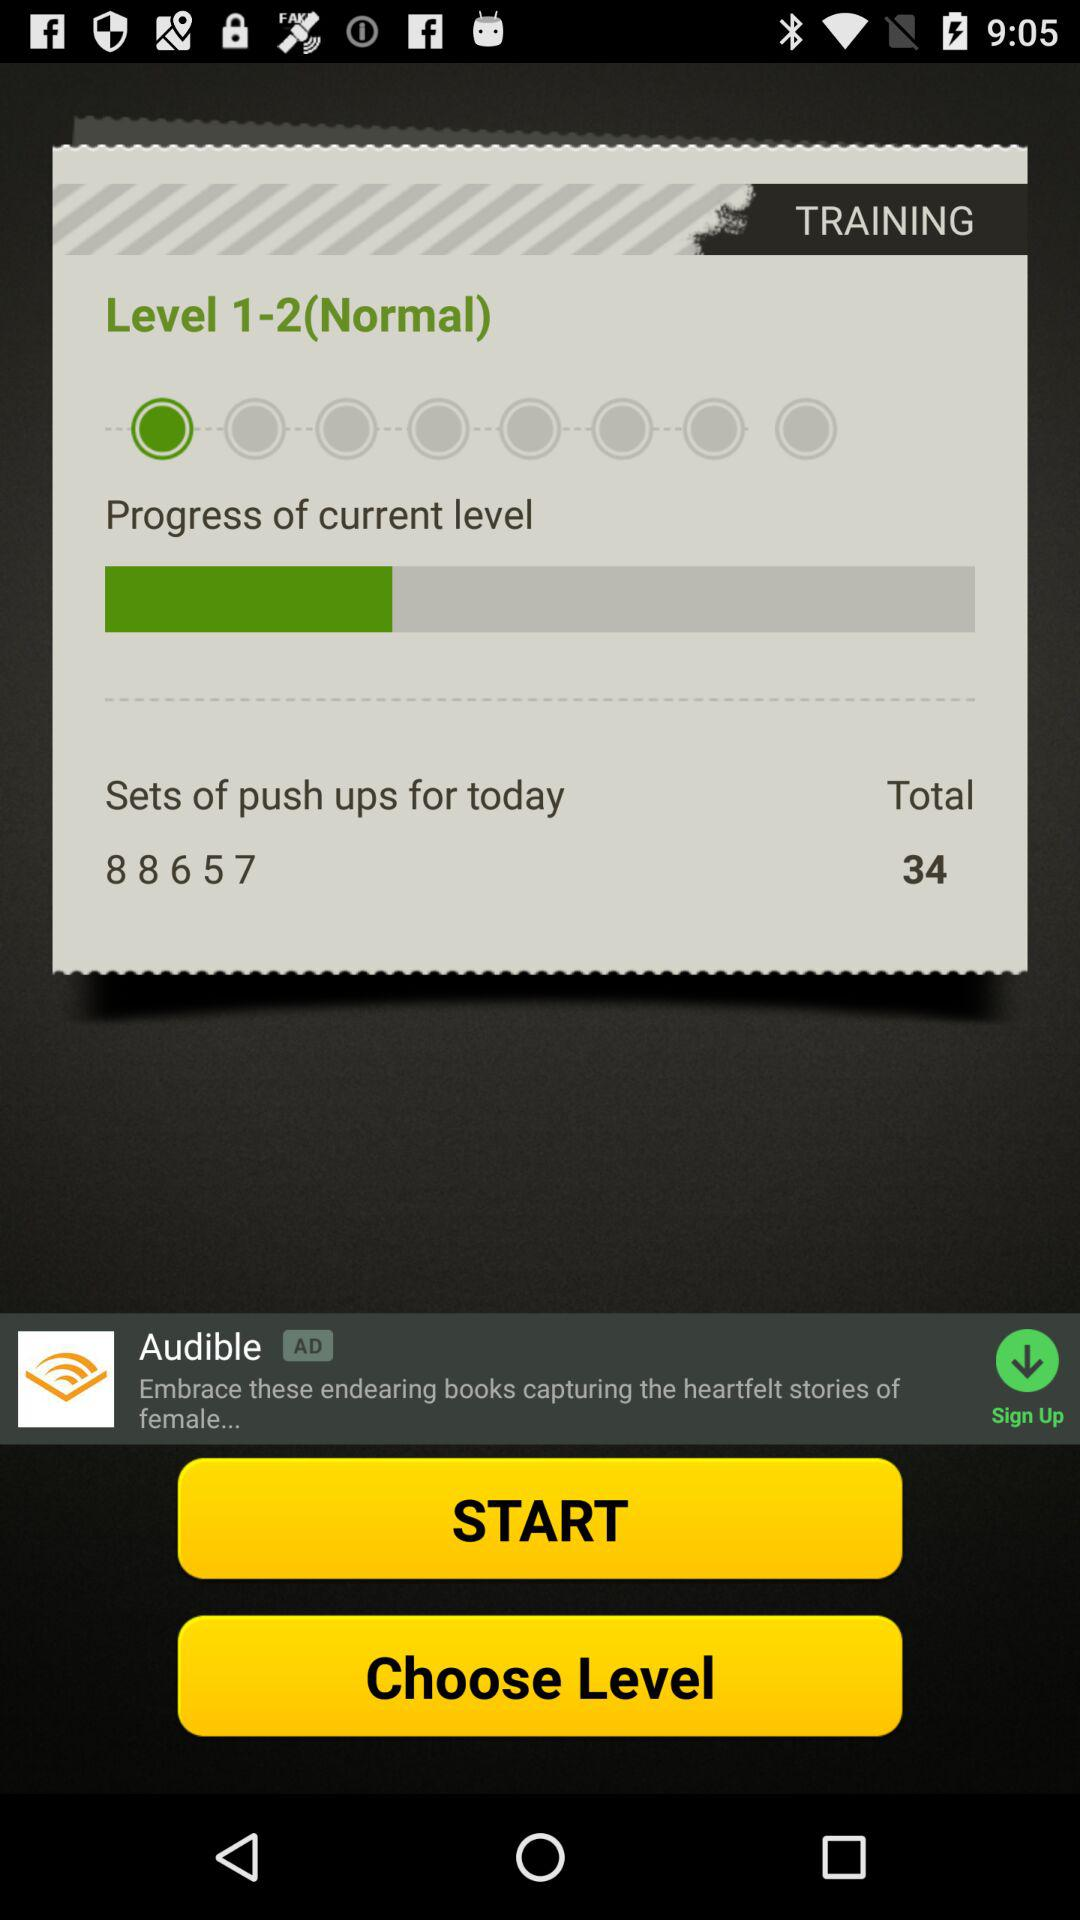How many more push up sets do I need to do today?
Answer the question using a single word or phrase. 34 